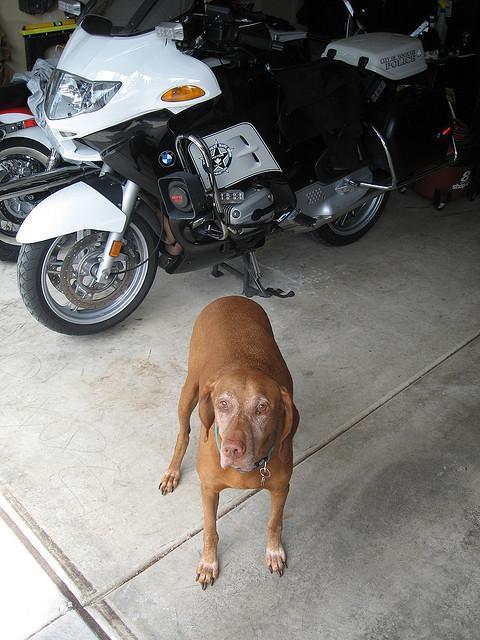How many motorcycles are there?
Give a very brief answer. 2. 